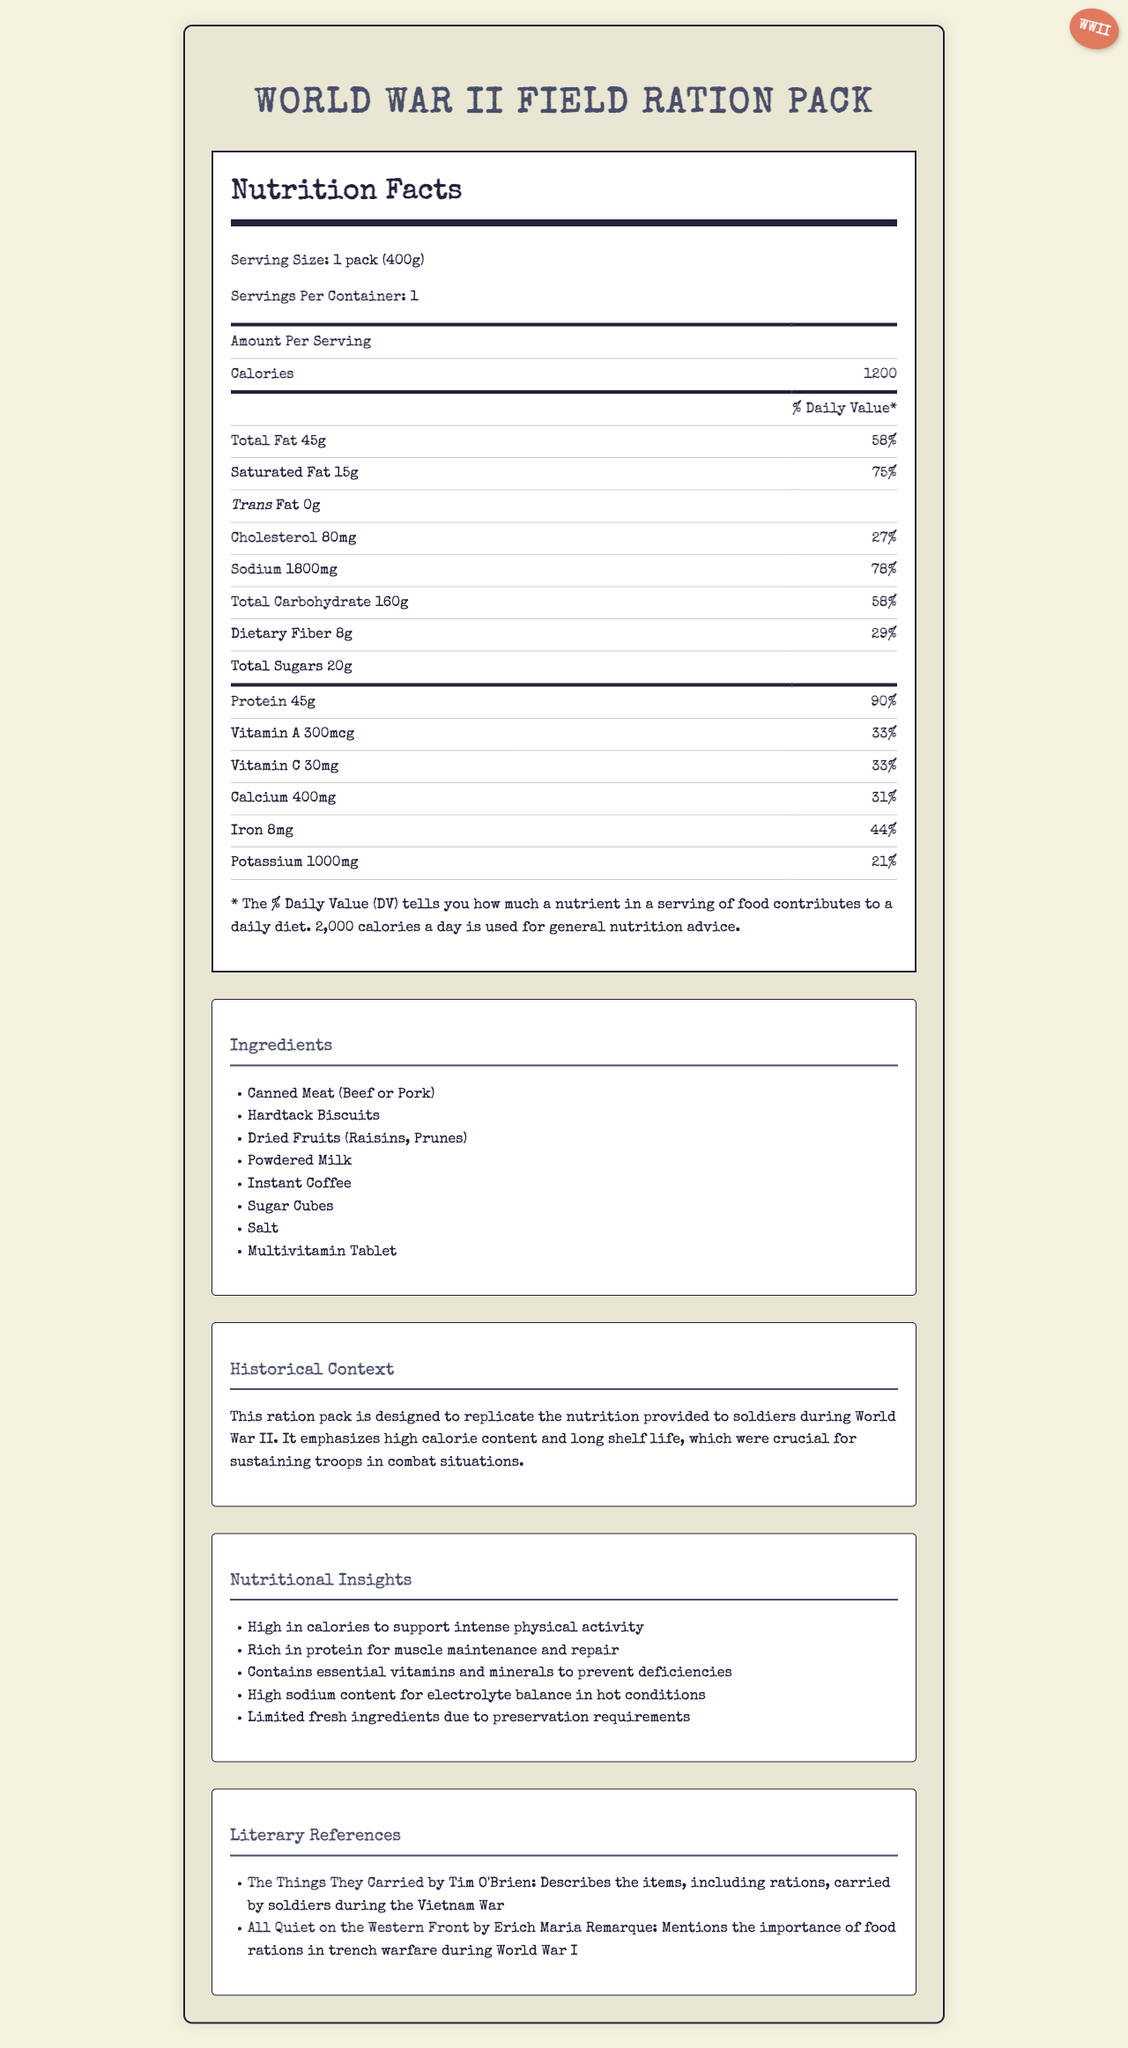what is the serving size of the World War II Field Ration Pack? The document clearly states that the serving size of the ration pack is "1 pack (400g)."
Answer: 1 pack (400g) how many calories are in one pack? The document lists the calorie content of the ration pack as 1200 per serving.
Answer: 1200 which ingredient in the ration pack is a source of protein? The ingredients list includes "Canned Meat (Beef or Pork)," which is a known source of protein.
Answer: Canned Meat (Beef or Pork) what is the total fat content and its daily value percentage? The document states that the total fat content is 45 grams, and this represents 58% of the daily value.
Answer: 45g, 58% what vitamins are included in the ration pack and their daily value percentages? The nutrition facts list Vitamin A and Vitamin C, each with a daily value of 33%.
Answer: Vitamin A: 33%, Vitamin C: 33% which nutrient has the highest daily value percentage? According to the document, sodium has the highest daily value percentage at 78%.
Answer: Sodium, 78% is there any trans fat in the ration pack? The document states that the trans fat content is 0 grams, indicating there is no trans fat in the ration pack.
Answer: No what is the main idea of the document? This summary encapsulates the overall purpose of the document which is to inform about the nutritional details and historical significance of the WWII ration pack.
Answer: The document provides the nutritional information and historical context for the World War II Field Ration Pack, detailing its high-calorie content, ingredients, and relevant literary references. what modern nutritional insight is provided regarding the ration pack? Among the nutritional insights, it is mentioned that the pack is high in calories to support intense physical activity.
Answer: High in calories to support intense physical activity how much calcium is in one serving of the ration pack, and what is its daily value percentage? The nutrition facts indicate that there is 400mg of calcium in one serving, representing 31% of the daily value.
Answer: 400mg, 31% how many sugars are in the ration pack? The document specifies that the total sugar content is 20 grams.
Answer: 20g what nutrient is mentioned as having a significant role in electrolyte balance in hot conditions? The nutritional insights section notes that the high sodium content is important for maintaining electrolyte balance in hot conditions.
Answer: Sodium what is a typical usage scenario for these rations during WWII according to the historical context? The historical context explains that these rations were designed to provide high calories and have a long shelf life, crucial for sustaining soldiers in combat.
Answer: Sustaining troops in combat situations due to high-calorie content and long shelf-life. why is it not possible to determine the exact source of food the soldiers received during WWII from this document? The document provides a generalized ingredient list and nutritional breakdown but doesn't specify specific sources or brands of food provisions.
Answer: Cannot be determined 